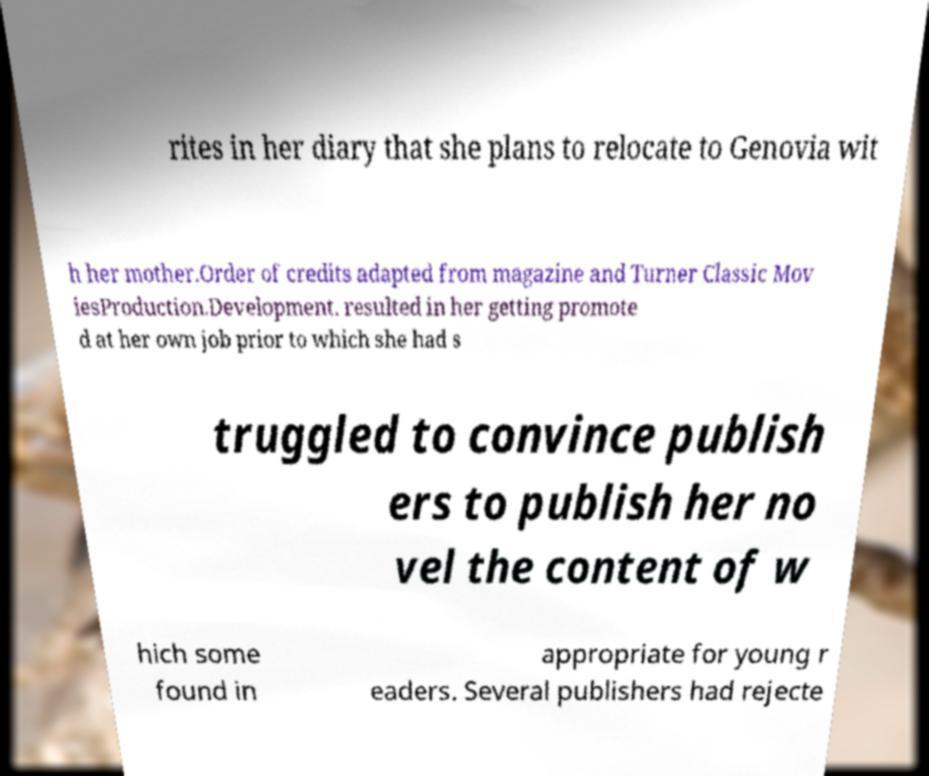Please identify and transcribe the text found in this image. rites in her diary that she plans to relocate to Genovia wit h her mother.Order of credits adapted from magazine and Turner Classic Mov iesProduction.Development. resulted in her getting promote d at her own job prior to which she had s truggled to convince publish ers to publish her no vel the content of w hich some found in appropriate for young r eaders. Several publishers had rejecte 